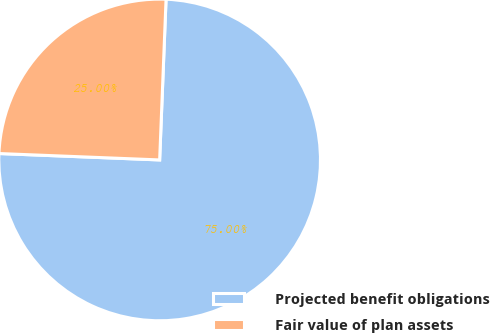<chart> <loc_0><loc_0><loc_500><loc_500><pie_chart><fcel>Projected benefit obligations<fcel>Fair value of plan assets<nl><fcel>75.0%<fcel>25.0%<nl></chart> 